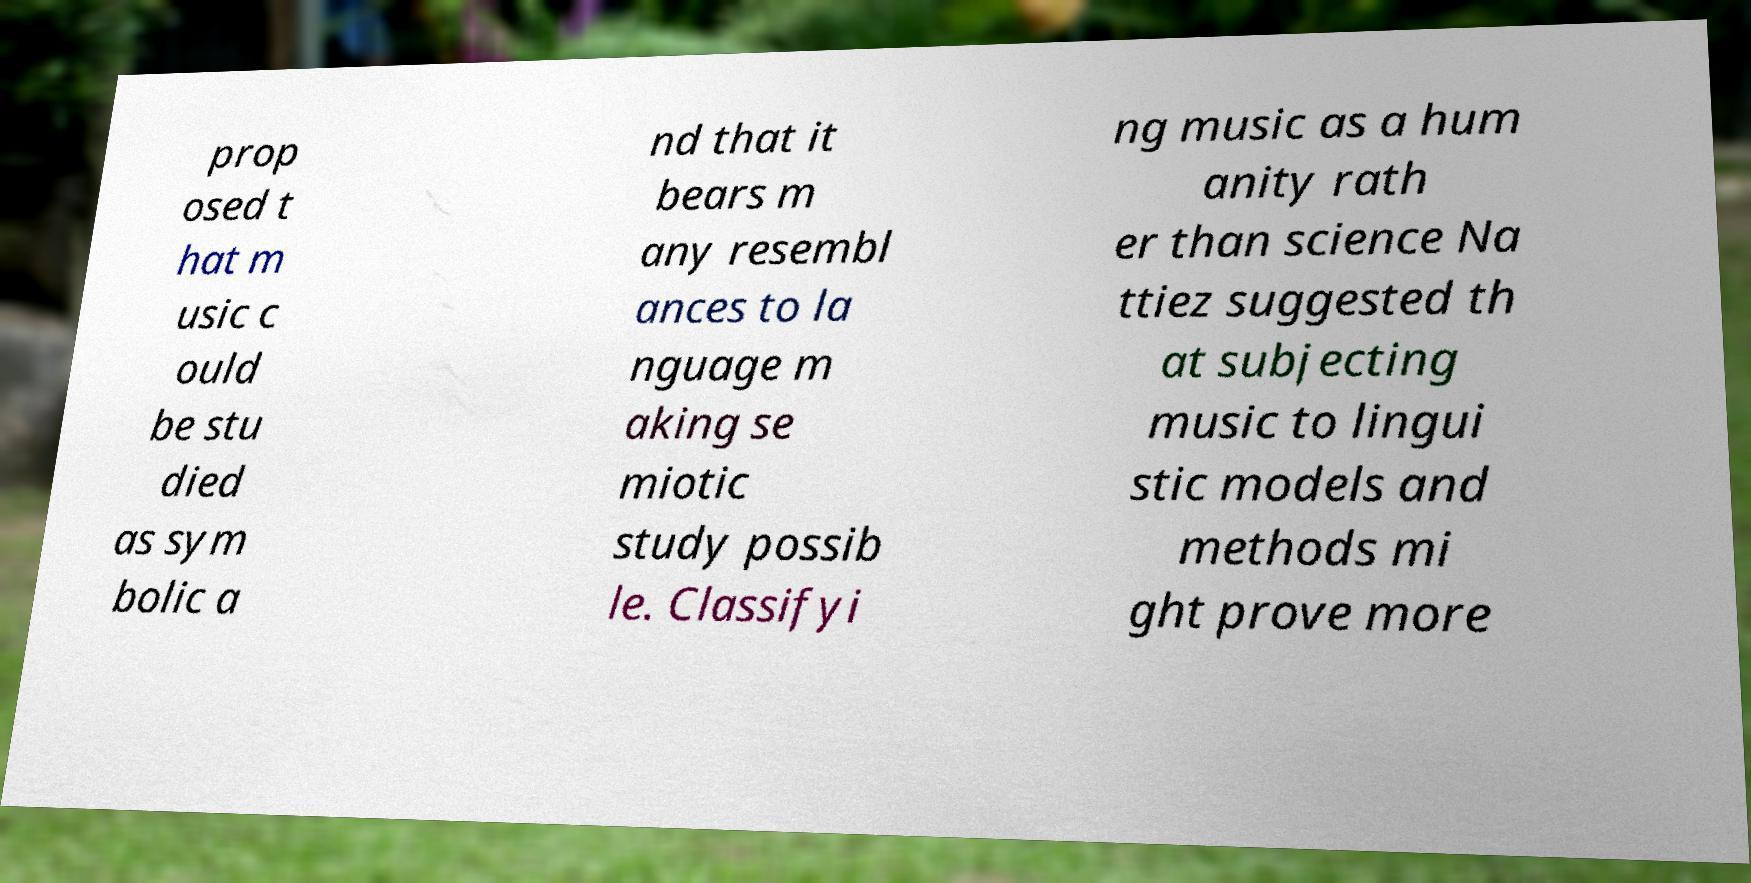For documentation purposes, I need the text within this image transcribed. Could you provide that? prop osed t hat m usic c ould be stu died as sym bolic a nd that it bears m any resembl ances to la nguage m aking se miotic study possib le. Classifyi ng music as a hum anity rath er than science Na ttiez suggested th at subjecting music to lingui stic models and methods mi ght prove more 